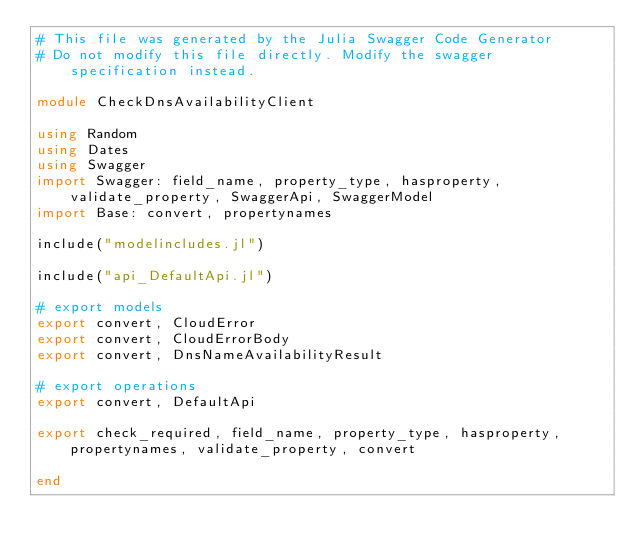<code> <loc_0><loc_0><loc_500><loc_500><_Julia_># This file was generated by the Julia Swagger Code Generator
# Do not modify this file directly. Modify the swagger specification instead.

module CheckDnsAvailabilityClient

using Random
using Dates
using Swagger
import Swagger: field_name, property_type, hasproperty, validate_property, SwaggerApi, SwaggerModel
import Base: convert, propertynames

include("modelincludes.jl")

include("api_DefaultApi.jl")

# export models
export convert, CloudError
export convert, CloudErrorBody
export convert, DnsNameAvailabilityResult

# export operations
export convert, DefaultApi

export check_required, field_name, property_type, hasproperty, propertynames, validate_property, convert

end
</code> 